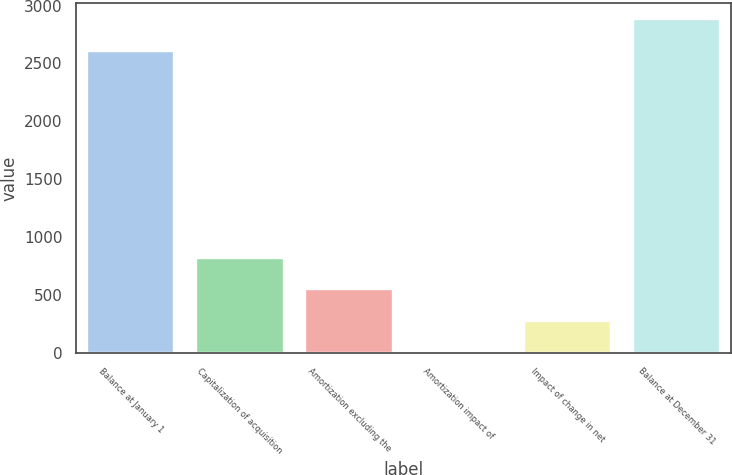Convert chart. <chart><loc_0><loc_0><loc_500><loc_500><bar_chart><fcel>Balance at January 1<fcel>Capitalization of acquisition<fcel>Amortization excluding the<fcel>Amortization impact of<fcel>Impact of change in net<fcel>Balance at December 31<nl><fcel>2608<fcel>821.7<fcel>549.8<fcel>6<fcel>277.9<fcel>2879.9<nl></chart> 